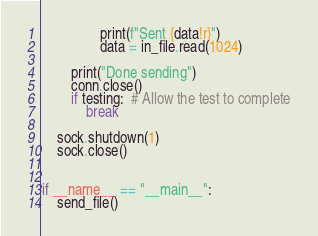<code> <loc_0><loc_0><loc_500><loc_500><_Python_>                print(f"Sent {data!r}")
                data = in_file.read(1024)

        print("Done sending")
        conn.close()
        if testing:  # Allow the test to complete
            break

    sock.shutdown(1)
    sock.close()


if __name__ == "__main__":
    send_file()
</code> 